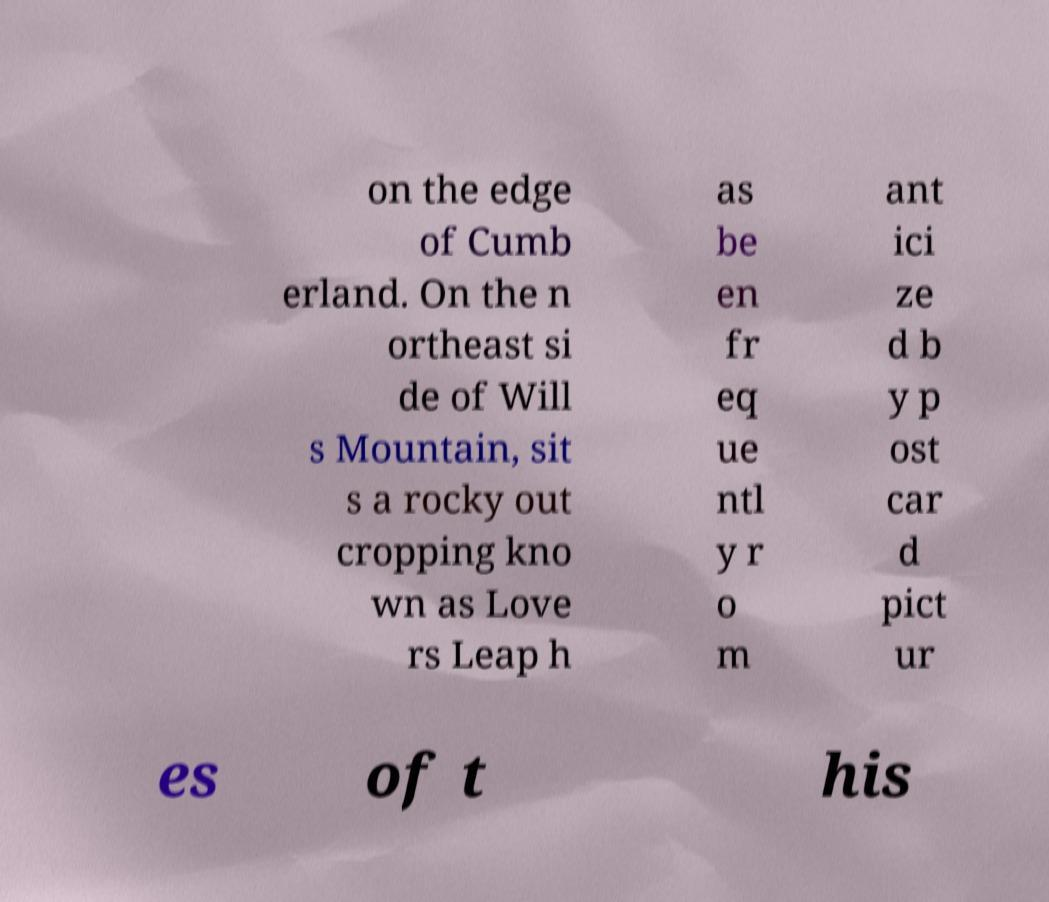What messages or text are displayed in this image? I need them in a readable, typed format. on the edge of Cumb erland. On the n ortheast si de of Will s Mountain, sit s a rocky out cropping kno wn as Love rs Leap h as be en fr eq ue ntl y r o m ant ici ze d b y p ost car d pict ur es of t his 